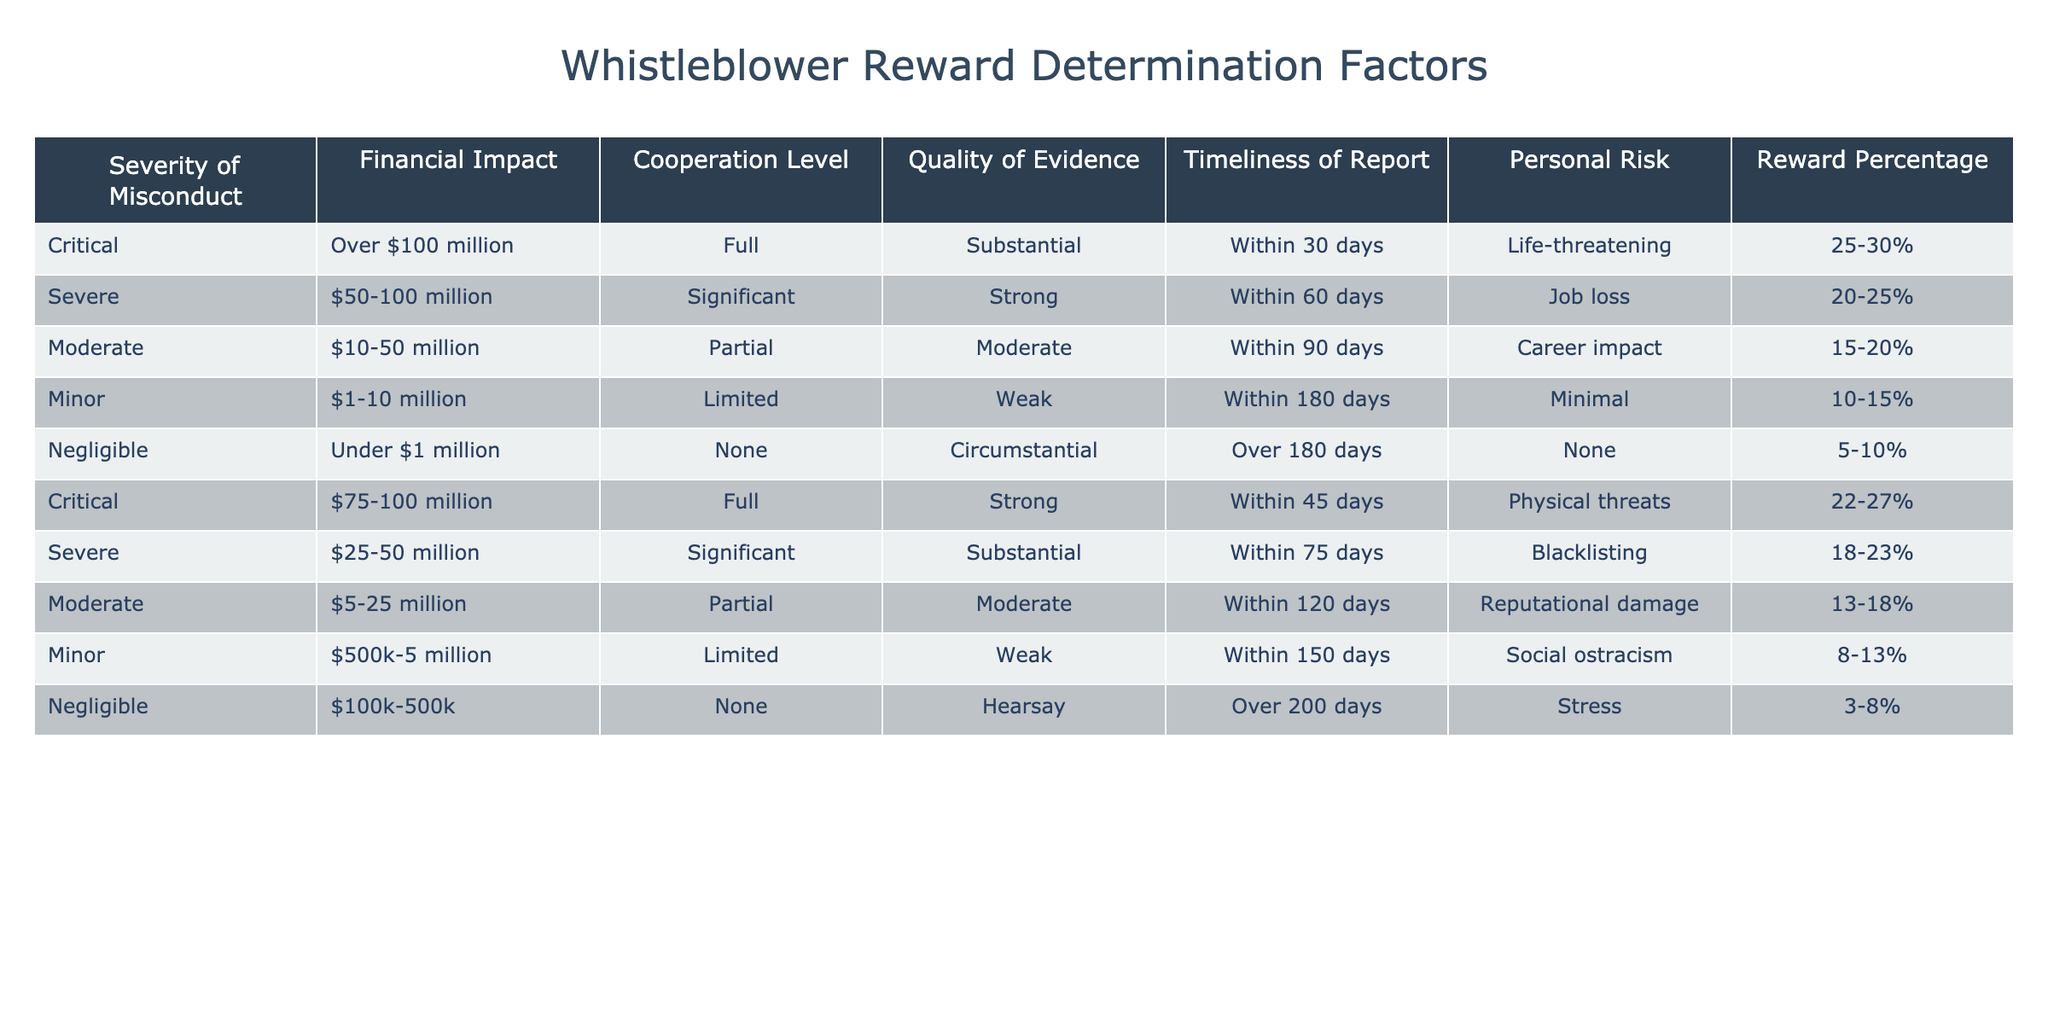What is the maximum reward percentage for whistleblowing on Critical misconduct? Referring to the table, the maximum reward percentage for Critical misconduct is found in the first row, which states "25-30%."
Answer: 25-30% What type of misconduct has a financial impact of Over $100 million and offers a reward percentage of 25-30%? The first row indicates that Critical misconduct with a financial impact of over $100 million corresponds to a reward percentage of 25-30%.
Answer: Critical Are there any instances of Severe misconduct that have a reward percentage above 20%? Yes, there are two instances of Severe misconduct with reward percentages: "20-25%" and "18-23%." The first value shows that the upper limit of 25% exceeds 20%.
Answer: Yes What is the average reward percentage for Minor misconduct? The values in the table for Minor misconduct are "10-15%" and "8-13%." To find the average, we take the midpoints: (10+15)/2 = 12.5 and (8+13)/2 = 10.5, then average these two midpoints: (12.5 + 10.5) / 2 = 11.5.
Answer: 11.5 Is there a case where Negligible misconduct has a financial impact of under $1 million and offers a reward percentage of 3-8%? Yes, the last row of the table indicates that Negligible misconduct, defined as having financial impacts of "Under $1 million," offers a reward of "3-8%."
Answer: Yes Which misconduct category has the highest financial impact and what is its cooperation level? The highest financial impact listed is "Over $100 million" under the Critical misconduct category, which has a cooperation level of "Full."
Answer: Critical, Full What is the relationship between Timeliness of Reports and the Personal Risk categories for Moderate misconduct? For Moderate misconduct, the Timeliness of Report is "Within 90 days" and the Personal Risk is "Career impact," suggesting a manageable timeframe for significant personal risk in reporting.
Answer: Manageable timeframe for significant personal risk How many different Reward Percentages are offered for Negligible misconduct? There are two instances of Negligible misconduct shown in the table: "5-10%" and "3-8%." Therefore, there are two unique reward percentages for Negligible misconduct.
Answer: 2 